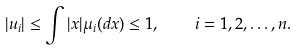Convert formula to latex. <formula><loc_0><loc_0><loc_500><loc_500>| u _ { i } | \leq \int | x | \mu _ { i } ( d x ) \leq 1 , \quad i = 1 , 2 , \dots , n .</formula> 